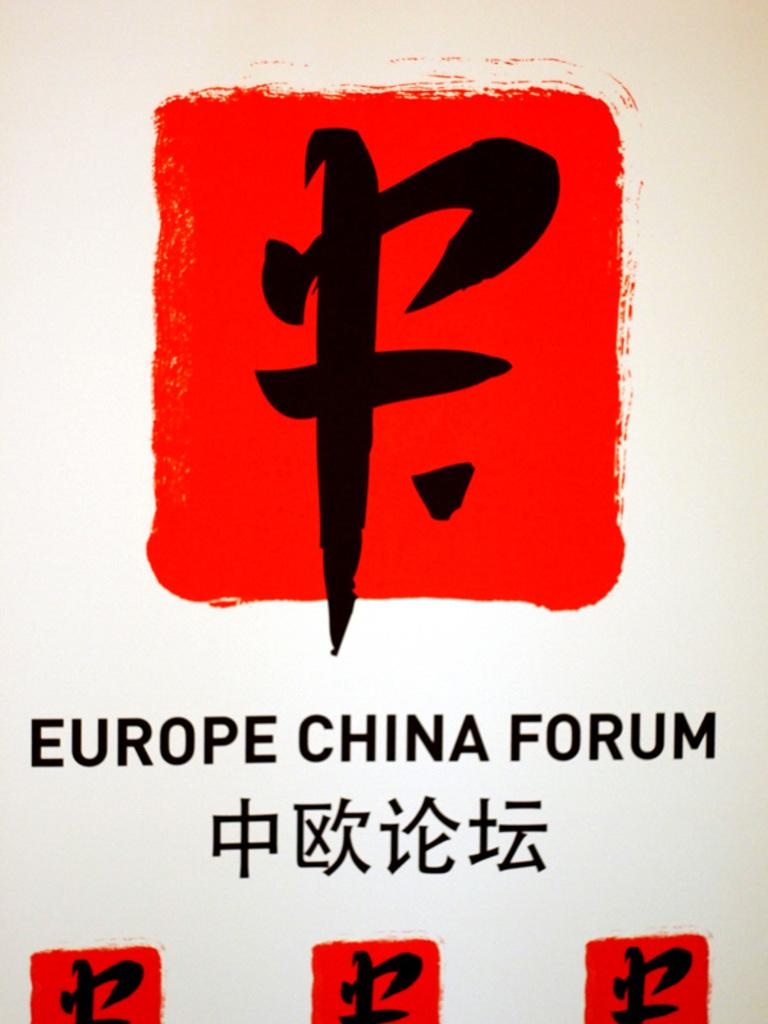<image>
Relay a brief, clear account of the picture shown. A red and white sign with Chinese symbols that say Europe China Forum. 